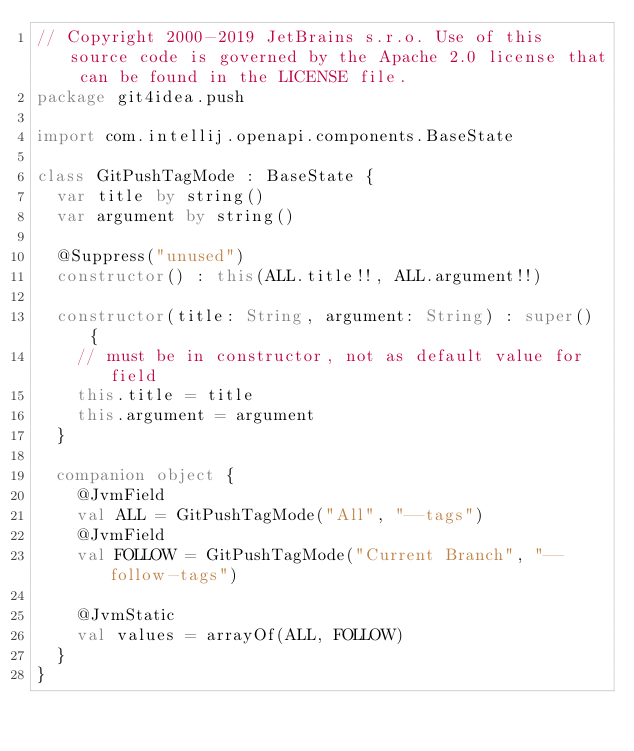Convert code to text. <code><loc_0><loc_0><loc_500><loc_500><_Kotlin_>// Copyright 2000-2019 JetBrains s.r.o. Use of this source code is governed by the Apache 2.0 license that can be found in the LICENSE file.
package git4idea.push

import com.intellij.openapi.components.BaseState

class GitPushTagMode : BaseState {
  var title by string()
  var argument by string()

  @Suppress("unused")
  constructor() : this(ALL.title!!, ALL.argument!!)

  constructor(title: String, argument: String) : super() {
    // must be in constructor, not as default value for field
    this.title = title
    this.argument = argument
  }

  companion object {
    @JvmField
    val ALL = GitPushTagMode("All", "--tags")
    @JvmField
    val FOLLOW = GitPushTagMode("Current Branch", "--follow-tags")

    @JvmStatic
    val values = arrayOf(ALL, FOLLOW)
  }
}
</code> 